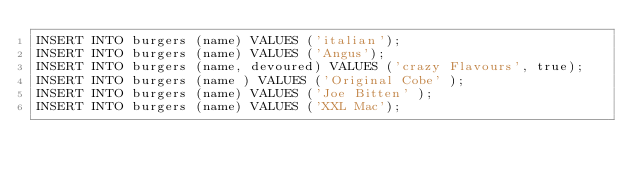<code> <loc_0><loc_0><loc_500><loc_500><_SQL_>INSERT INTO burgers (name) VALUES ('italian');
INSERT INTO burgers (name) VALUES ('Angus');
INSERT INTO burgers (name, devoured) VALUES ('crazy Flavours', true);
INSERT INTO burgers (name ) VALUES ('Original Cobe' );
INSERT INTO burgers (name) VALUES ('Joe Bitten' );
INSERT INTO burgers (name) VALUES ('XXL Mac');
</code> 